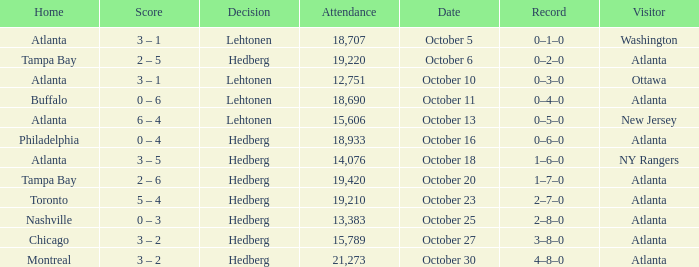What was the record on the game that was played on october 27? 3–8–0. 